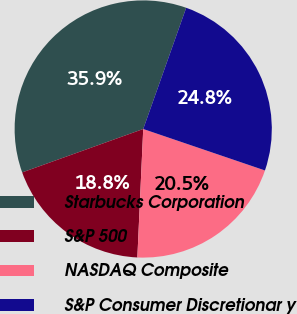Convert chart. <chart><loc_0><loc_0><loc_500><loc_500><pie_chart><fcel>Starbucks Corporation<fcel>S&P 500<fcel>NASDAQ Composite<fcel>S&P Consumer Discretionar y<nl><fcel>35.9%<fcel>18.79%<fcel>20.5%<fcel>24.8%<nl></chart> 